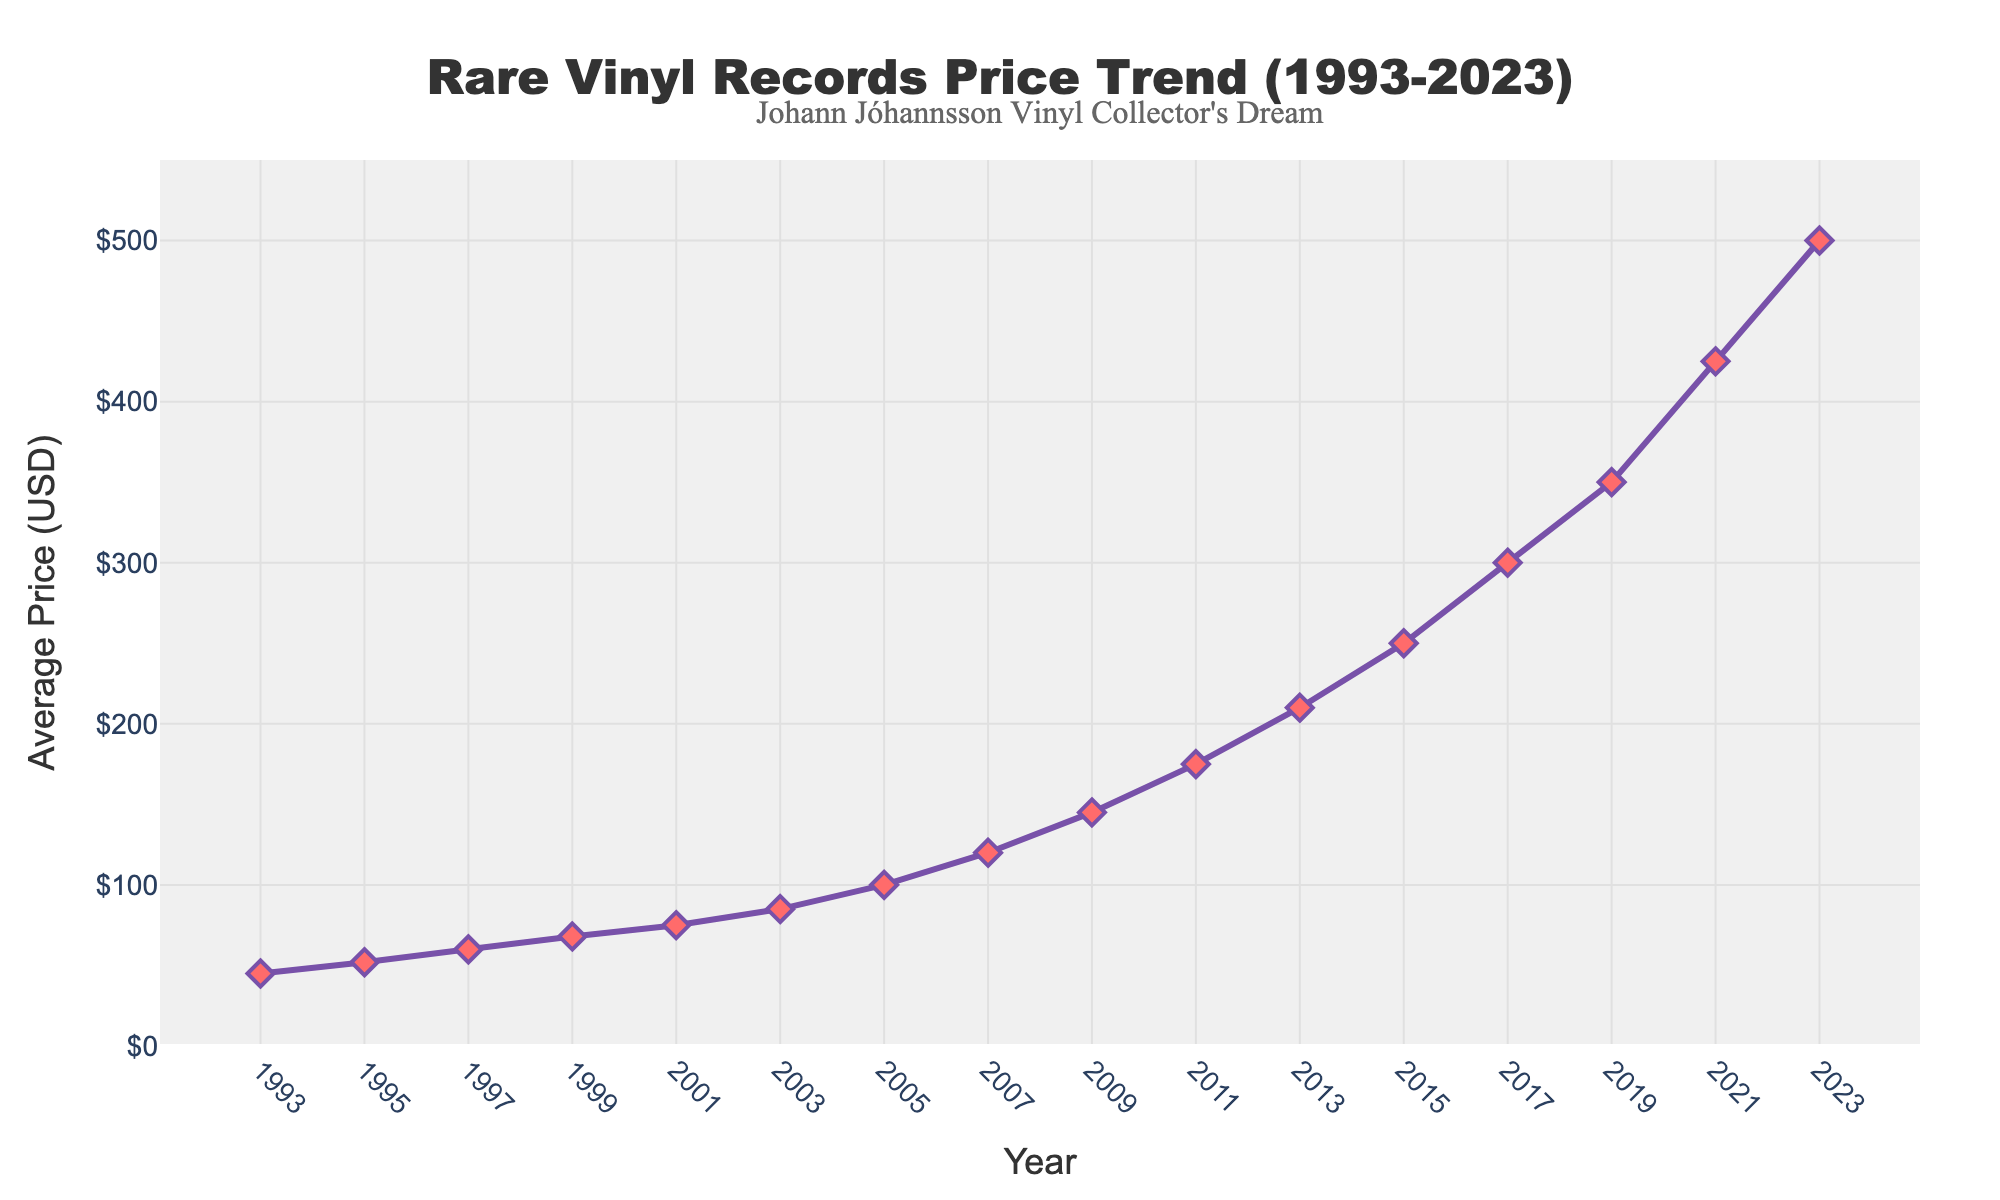What is the average price of rare vinyl records in 1995? Look at the data point corresponding to the year 1995 on the line chart. Observe the Y value, which represents the average price.
Answer: 52 USD Between which years did the average price of rare vinyl records increase the most? Analyze the slope of the line segments between each pair of adjacent years. The steepest slope indicates the largest increase. The steepest slope is between 2021 and 2023.
Answer: 2021-2023 What is the difference in the average price of rare vinyl records between 1993 and 2023? Check the average price for both 1993 and 2023. The difference is calculated as 500 (2023) - 45 (1993).
Answer: 455 USD How much did the average price of rare vinyl records increase between 2009 and 2013? Locate the points for 2009 and 2013. Subtract the 2009 price from the 2013 price: 210 (2013) - 145 (2009).
Answer: 65 USD In what year did the average price of rare vinyl records first exceed 100 USD? Follow the line from left to right until the Y value crosses the 100 USD mark. This occurs for the first time in 2005.
Answer: 2005 What is the median average price of rare vinyl records from 1993 to 2023? Sort the prices and find the middle value. Sorted: 45, 52, 60, 68, 75, 85, 100, 120, 145, 175, 210, 250, 300, 350, 425, 500. The median is (145 + 175) / 2 = 160.
Answer: 160 USD Which year experienced a higher average price: 2015 or 2017? Compare the Y values for the years 2015 and 2017 on the line chart. 2017 is higher.
Answer: 2017 How many years did it take for the average price to increase from 75 USD to 250 USD? Identify the years when the prices were 75 USD (2001) and 250 USD (2015). Subtract the earlier year from the later year: 2015 - 2001.
Answer: 14 years Was there ever a year when the average price decreased compared to the previous year? Observe the trend in the line chart. There are no downward slopes, so the price did not decrease any year.
Answer: No 